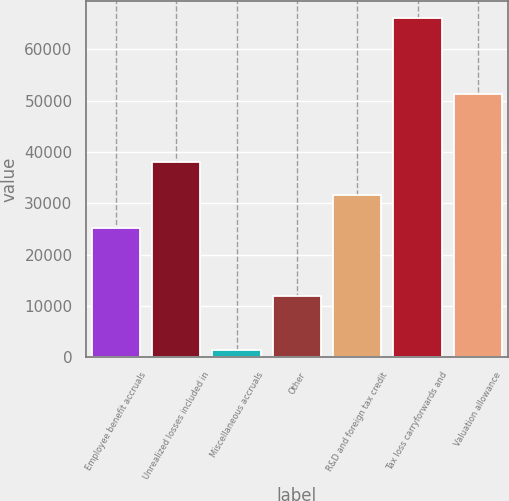<chart> <loc_0><loc_0><loc_500><loc_500><bar_chart><fcel>Employee benefit accruals<fcel>Unrealized losses included in<fcel>Miscellaneous accruals<fcel>Other<fcel>R&D and foreign tax credit<fcel>Tax loss carryforwards and<fcel>Valuation allowance<nl><fcel>25085<fcel>37999.8<fcel>1457<fcel>11853<fcel>31542.4<fcel>66031<fcel>51324<nl></chart> 